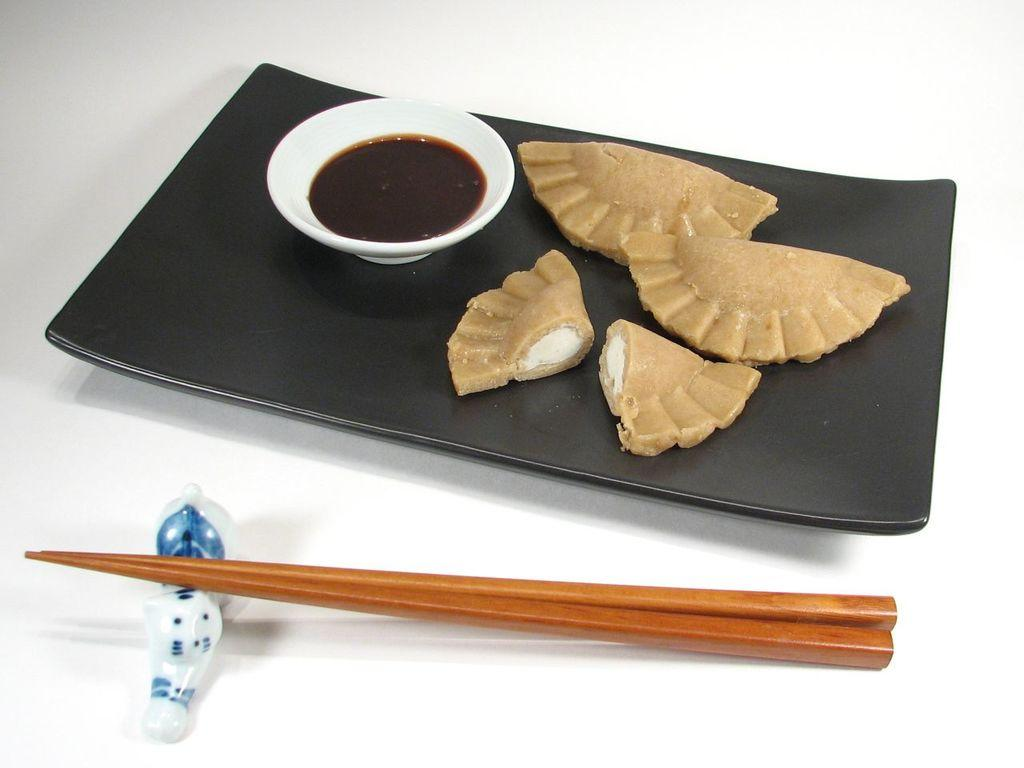What is on the plate in the image? The plate has food on the right side. What else is on the plate besides the food? There is a sauce bowl on the left side of the plate. What utensils are present in the image? Chopsticks are present in the image. Where are the chopsticks located in relation to the plate? The chopsticks are in front of the plate. Is there anything supporting the chopsticks? Yes, there is a plastic supporter below the chopsticks. How many men are visible in the image? There are no men visible in the image; it only features a plate, food, a sauce bowl, chopsticks, and a plastic supporter. What type of shock can be seen in the image? There is no shock present in the image; it is a still image of a plate with food, a sauce bowl, chopsticks, and a plastic supporter. 